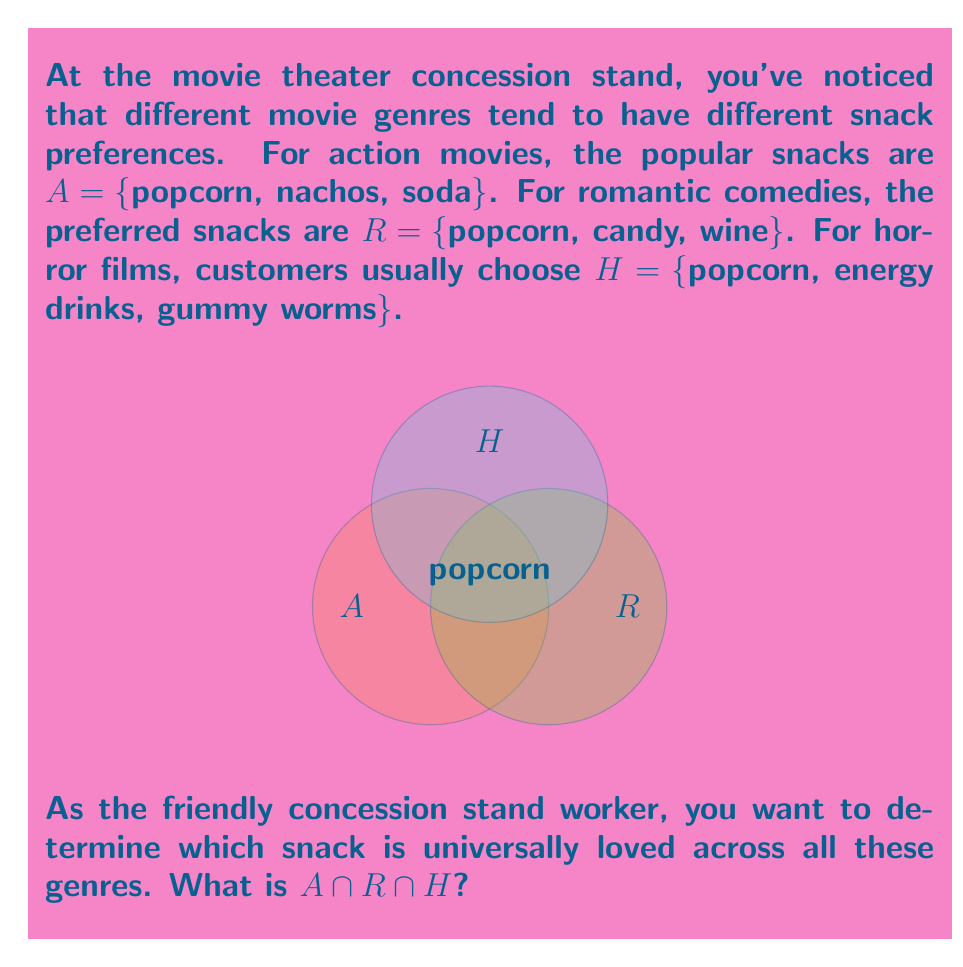Help me with this question. To find the intersection of these three sets, we need to identify the elements that are common to all of them. Let's approach this step-by-step:

1) First, let's list out the elements of each set:
   $A = \{popcorn, nachos, soda\}$
   $R = \{popcorn, candy, wine\}$
   $H = \{popcorn, energy drinks, gummy worms\}$

2) Now, we need to find the elements that appear in all three sets.

3) Looking at set $A$, we see:
   - "popcorn" is also in $R$ and $H$
   - "nachos" is not in $R$ or $H$
   - "soda" is not in $R$ or $H$

4) Therefore, the only element that appears in all three sets is "popcorn".

5) We can write this mathematically as:
   $A \cap R \cap H = \{popcorn\}$

This result means that popcorn is the snack that is universally loved across action movies, romantic comedies, and horror films.
Answer: $\{popcorn\}$ 